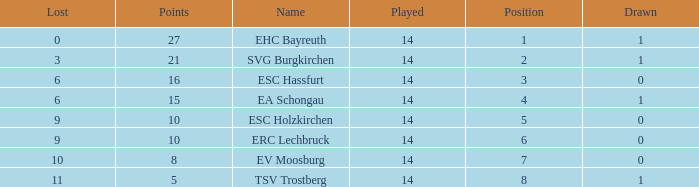What's the most points for Ea Schongau with more than 1 drawn? None. 